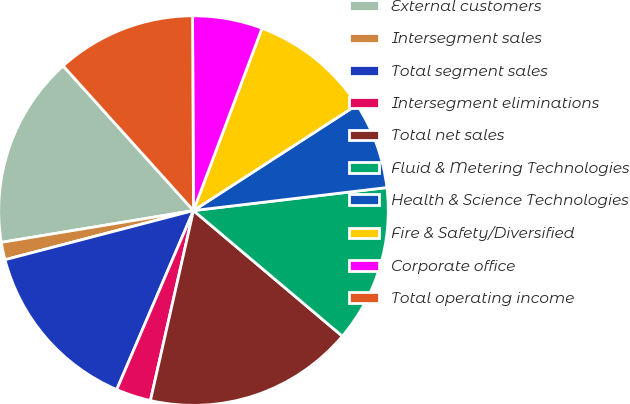<chart> <loc_0><loc_0><loc_500><loc_500><pie_chart><fcel>External customers<fcel>Intersegment sales<fcel>Total segment sales<fcel>Intersegment eliminations<fcel>Total net sales<fcel>Fluid & Metering Technologies<fcel>Health & Science Technologies<fcel>Fire & Safety/Diversified<fcel>Corporate office<fcel>Total operating income<nl><fcel>15.94%<fcel>1.45%<fcel>14.49%<fcel>2.9%<fcel>17.39%<fcel>13.04%<fcel>7.25%<fcel>10.14%<fcel>5.8%<fcel>11.59%<nl></chart> 